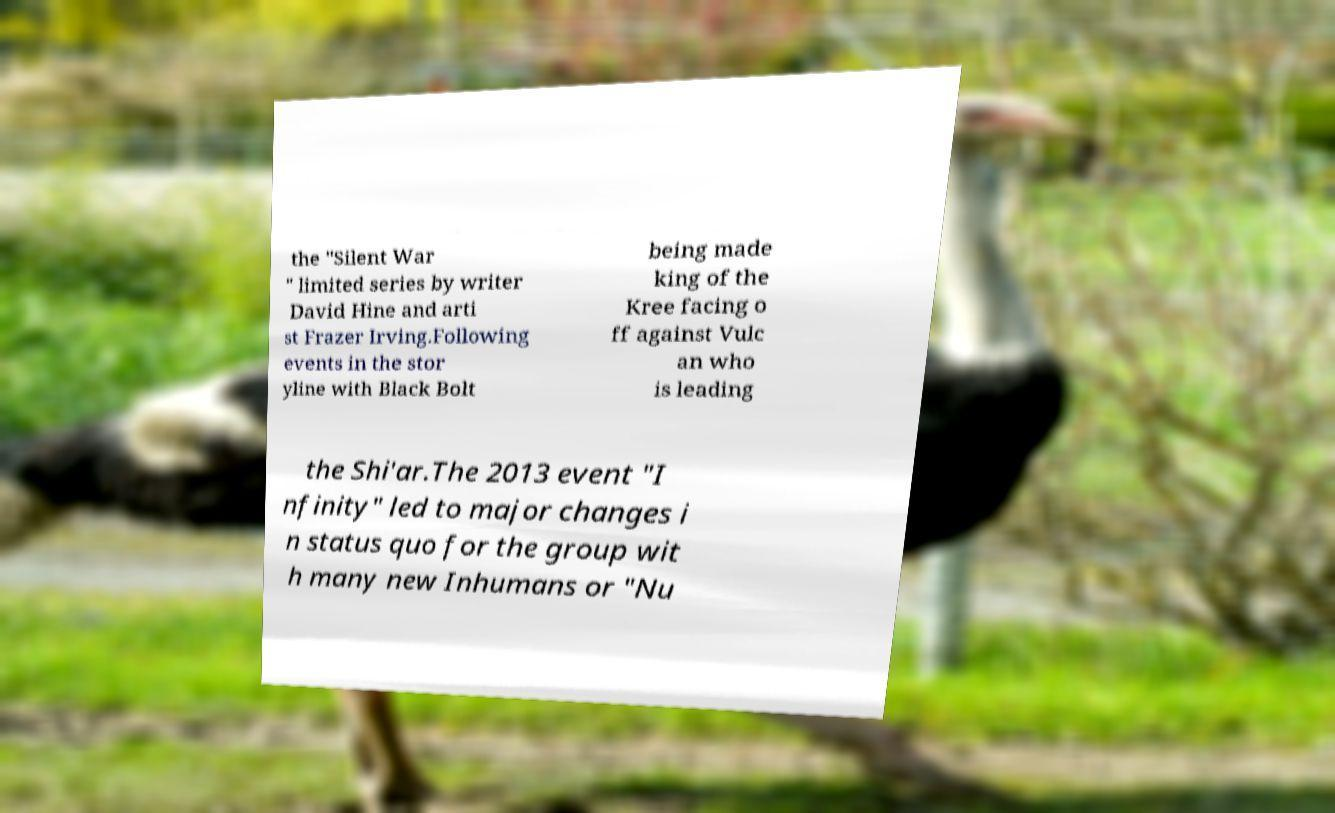For documentation purposes, I need the text within this image transcribed. Could you provide that? the "Silent War " limited series by writer David Hine and arti st Frazer Irving.Following events in the stor yline with Black Bolt being made king of the Kree facing o ff against Vulc an who is leading the Shi'ar.The 2013 event "I nfinity" led to major changes i n status quo for the group wit h many new Inhumans or "Nu 